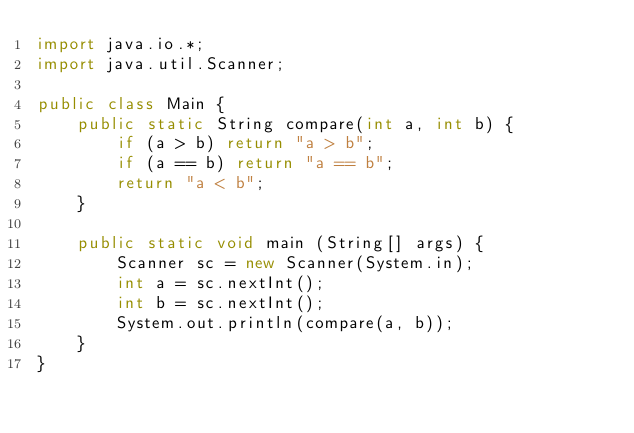<code> <loc_0><loc_0><loc_500><loc_500><_Java_>import java.io.*;
import java.util.Scanner;
 
public class Main {
    public static String compare(int a, int b) {
        if (a > b) return "a > b";
        if (a == b) return "a == b";
        return "a < b";
    }
 
    public static void main (String[] args) {
        Scanner sc = new Scanner(System.in);
        int a = sc.nextInt();
        int b = sc.nextInt();
        System.out.println(compare(a, b));
    }
}
</code> 